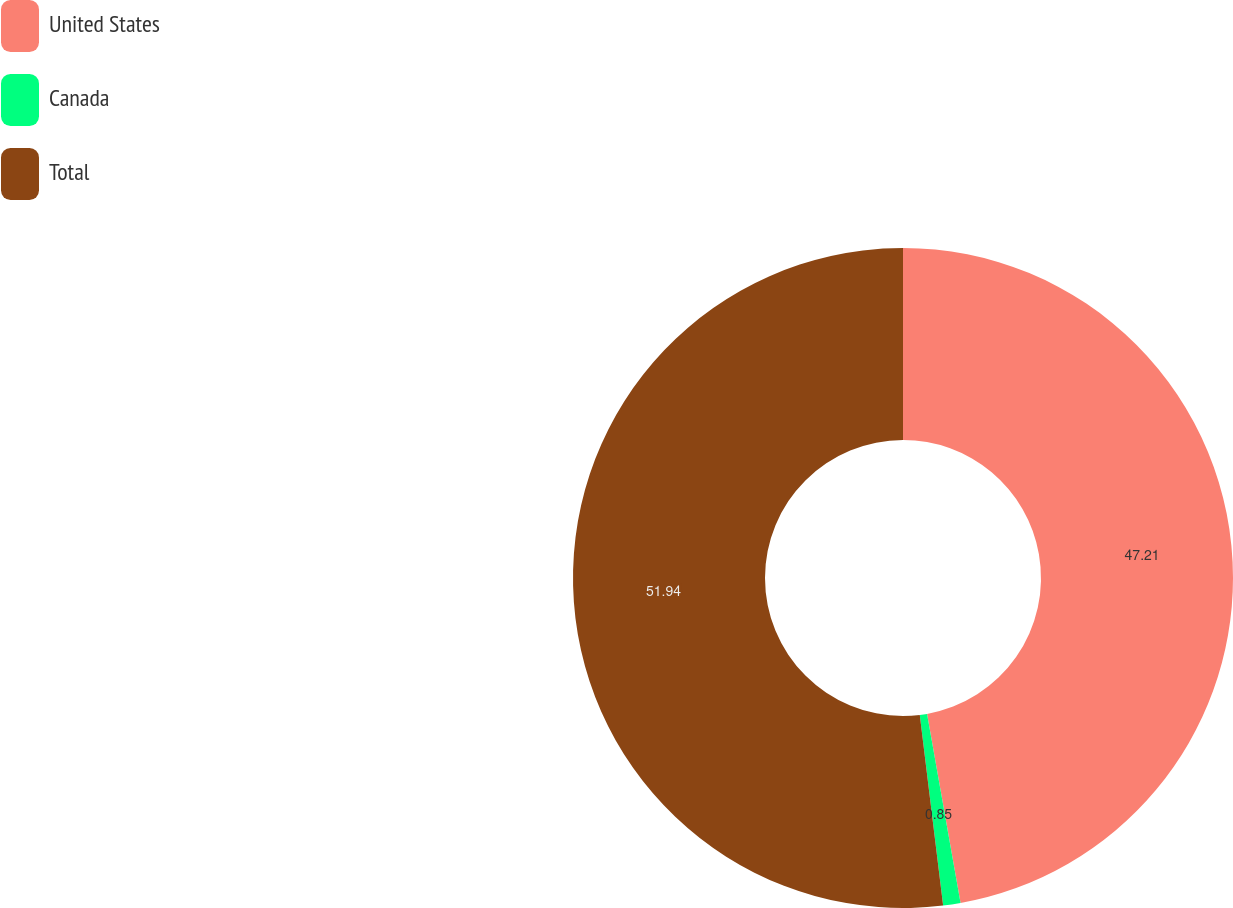Convert chart to OTSL. <chart><loc_0><loc_0><loc_500><loc_500><pie_chart><fcel>United States<fcel>Canada<fcel>Total<nl><fcel>47.21%<fcel>0.85%<fcel>51.94%<nl></chart> 